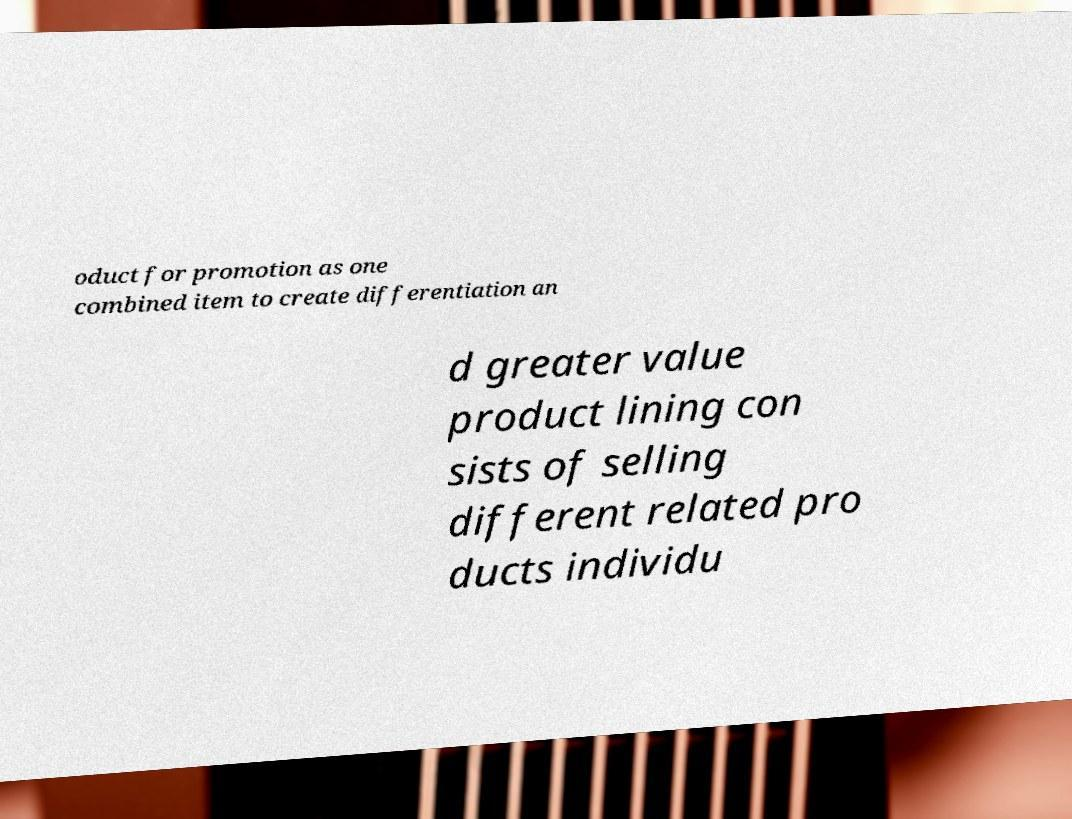Please read and relay the text visible in this image. What does it say? oduct for promotion as one combined item to create differentiation an d greater value product lining con sists of selling different related pro ducts individu 